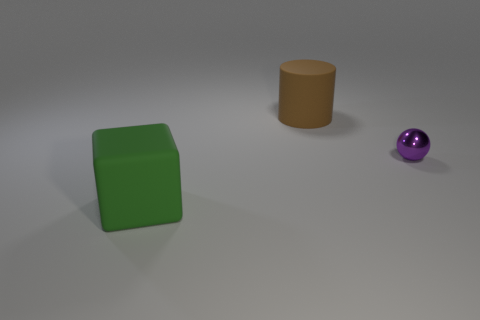Add 2 large brown objects. How many objects exist? 5 Subtract all blocks. How many objects are left? 2 Subtract 1 cylinders. How many cylinders are left? 0 Subtract all brown cylinders. How many red cubes are left? 0 Subtract all big blue metal objects. Subtract all big green matte objects. How many objects are left? 2 Add 1 matte things. How many matte things are left? 3 Add 1 small purple metallic objects. How many small purple metallic objects exist? 2 Subtract 0 gray balls. How many objects are left? 3 